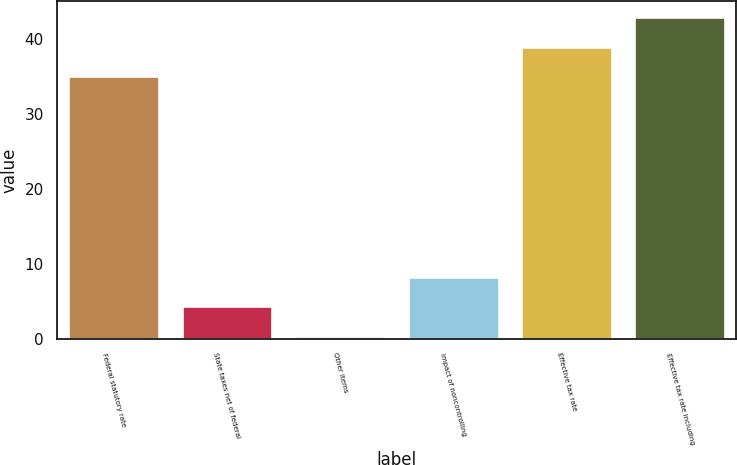Convert chart to OTSL. <chart><loc_0><loc_0><loc_500><loc_500><bar_chart><fcel>Federal statutory rate<fcel>State taxes net of federal<fcel>Other items<fcel>Impact of noncontrolling<fcel>Effective tax rate<fcel>Effective tax rate including<nl><fcel>35<fcel>4.34<fcel>0.4<fcel>8.28<fcel>38.94<fcel>42.88<nl></chart> 